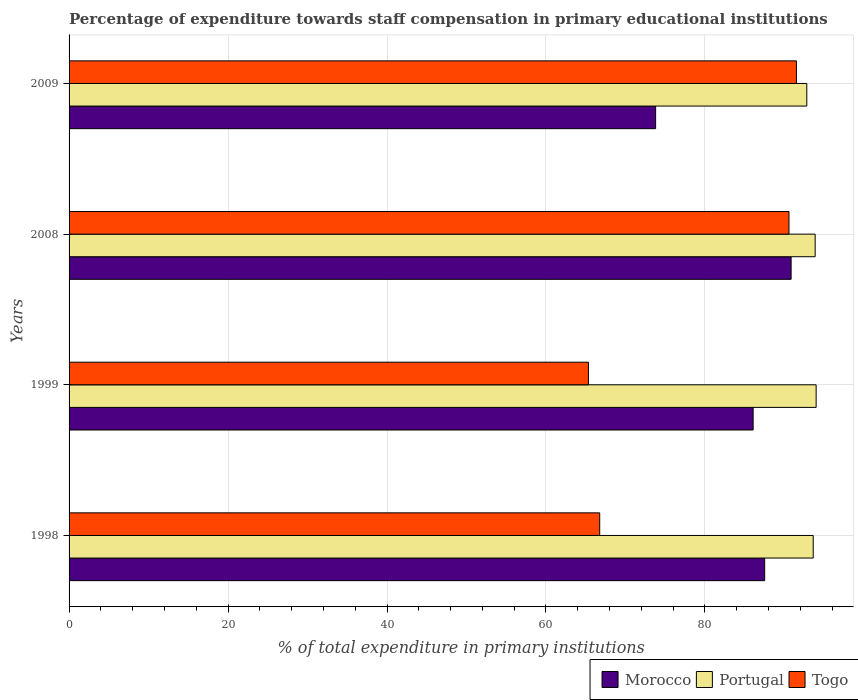How many different coloured bars are there?
Your response must be concise. 3. Are the number of bars per tick equal to the number of legend labels?
Your answer should be compact. Yes. What is the label of the 4th group of bars from the top?
Keep it short and to the point. 1998. In how many cases, is the number of bars for a given year not equal to the number of legend labels?
Ensure brevity in your answer.  0. What is the percentage of expenditure towards staff compensation in Togo in 2009?
Make the answer very short. 91.51. Across all years, what is the maximum percentage of expenditure towards staff compensation in Portugal?
Make the answer very short. 93.99. Across all years, what is the minimum percentage of expenditure towards staff compensation in Togo?
Ensure brevity in your answer.  65.34. In which year was the percentage of expenditure towards staff compensation in Portugal minimum?
Ensure brevity in your answer.  2009. What is the total percentage of expenditure towards staff compensation in Portugal in the graph?
Your response must be concise. 374.3. What is the difference between the percentage of expenditure towards staff compensation in Togo in 1999 and that in 2009?
Ensure brevity in your answer.  -26.17. What is the difference between the percentage of expenditure towards staff compensation in Morocco in 2009 and the percentage of expenditure towards staff compensation in Portugal in 1998?
Give a very brief answer. -19.83. What is the average percentage of expenditure towards staff compensation in Portugal per year?
Your response must be concise. 93.58. In the year 2009, what is the difference between the percentage of expenditure towards staff compensation in Morocco and percentage of expenditure towards staff compensation in Portugal?
Your response must be concise. -19.02. What is the ratio of the percentage of expenditure towards staff compensation in Togo in 2008 to that in 2009?
Provide a succinct answer. 0.99. Is the percentage of expenditure towards staff compensation in Portugal in 1998 less than that in 1999?
Offer a terse response. Yes. What is the difference between the highest and the second highest percentage of expenditure towards staff compensation in Morocco?
Keep it short and to the point. 3.33. What is the difference between the highest and the lowest percentage of expenditure towards staff compensation in Portugal?
Provide a succinct answer. 1.18. What does the 3rd bar from the top in 1998 represents?
Give a very brief answer. Morocco. What does the 2nd bar from the bottom in 1998 represents?
Provide a short and direct response. Portugal. How many bars are there?
Offer a very short reply. 12. What is the difference between two consecutive major ticks on the X-axis?
Your response must be concise. 20. Are the values on the major ticks of X-axis written in scientific E-notation?
Provide a succinct answer. No. Does the graph contain grids?
Offer a terse response. Yes. How many legend labels are there?
Your answer should be very brief. 3. How are the legend labels stacked?
Give a very brief answer. Horizontal. What is the title of the graph?
Offer a terse response. Percentage of expenditure towards staff compensation in primary educational institutions. Does "Mauritania" appear as one of the legend labels in the graph?
Keep it short and to the point. No. What is the label or title of the X-axis?
Give a very brief answer. % of total expenditure in primary institutions. What is the label or title of the Y-axis?
Your answer should be compact. Years. What is the % of total expenditure in primary institutions of Morocco in 1998?
Your answer should be compact. 87.52. What is the % of total expenditure in primary institutions of Portugal in 1998?
Your answer should be very brief. 93.63. What is the % of total expenditure in primary institutions in Togo in 1998?
Make the answer very short. 66.76. What is the % of total expenditure in primary institutions of Morocco in 1999?
Provide a succinct answer. 86.07. What is the % of total expenditure in primary institutions in Portugal in 1999?
Your response must be concise. 93.99. What is the % of total expenditure in primary institutions of Togo in 1999?
Your answer should be very brief. 65.34. What is the % of total expenditure in primary institutions of Morocco in 2008?
Keep it short and to the point. 90.84. What is the % of total expenditure in primary institutions in Portugal in 2008?
Make the answer very short. 93.87. What is the % of total expenditure in primary institutions in Togo in 2008?
Your answer should be compact. 90.57. What is the % of total expenditure in primary institutions of Morocco in 2009?
Provide a succinct answer. 73.8. What is the % of total expenditure in primary institutions in Portugal in 2009?
Your answer should be compact. 92.82. What is the % of total expenditure in primary institutions of Togo in 2009?
Provide a short and direct response. 91.51. Across all years, what is the maximum % of total expenditure in primary institutions of Morocco?
Provide a short and direct response. 90.84. Across all years, what is the maximum % of total expenditure in primary institutions in Portugal?
Provide a succinct answer. 93.99. Across all years, what is the maximum % of total expenditure in primary institutions in Togo?
Give a very brief answer. 91.51. Across all years, what is the minimum % of total expenditure in primary institutions in Morocco?
Provide a short and direct response. 73.8. Across all years, what is the minimum % of total expenditure in primary institutions of Portugal?
Your response must be concise. 92.82. Across all years, what is the minimum % of total expenditure in primary institutions in Togo?
Ensure brevity in your answer.  65.34. What is the total % of total expenditure in primary institutions of Morocco in the graph?
Make the answer very short. 338.22. What is the total % of total expenditure in primary institutions of Portugal in the graph?
Offer a terse response. 374.3. What is the total % of total expenditure in primary institutions of Togo in the graph?
Provide a succinct answer. 314.19. What is the difference between the % of total expenditure in primary institutions of Morocco in 1998 and that in 1999?
Your answer should be very brief. 1.45. What is the difference between the % of total expenditure in primary institutions of Portugal in 1998 and that in 1999?
Your answer should be compact. -0.37. What is the difference between the % of total expenditure in primary institutions in Togo in 1998 and that in 1999?
Your response must be concise. 1.42. What is the difference between the % of total expenditure in primary institutions of Morocco in 1998 and that in 2008?
Give a very brief answer. -3.33. What is the difference between the % of total expenditure in primary institutions of Portugal in 1998 and that in 2008?
Keep it short and to the point. -0.24. What is the difference between the % of total expenditure in primary institutions of Togo in 1998 and that in 2008?
Offer a terse response. -23.81. What is the difference between the % of total expenditure in primary institutions in Morocco in 1998 and that in 2009?
Ensure brevity in your answer.  13.72. What is the difference between the % of total expenditure in primary institutions in Portugal in 1998 and that in 2009?
Ensure brevity in your answer.  0.81. What is the difference between the % of total expenditure in primary institutions in Togo in 1998 and that in 2009?
Offer a terse response. -24.75. What is the difference between the % of total expenditure in primary institutions in Morocco in 1999 and that in 2008?
Your answer should be very brief. -4.78. What is the difference between the % of total expenditure in primary institutions in Portugal in 1999 and that in 2008?
Ensure brevity in your answer.  0.12. What is the difference between the % of total expenditure in primary institutions in Togo in 1999 and that in 2008?
Keep it short and to the point. -25.23. What is the difference between the % of total expenditure in primary institutions of Morocco in 1999 and that in 2009?
Give a very brief answer. 12.27. What is the difference between the % of total expenditure in primary institutions in Portugal in 1999 and that in 2009?
Your answer should be very brief. 1.18. What is the difference between the % of total expenditure in primary institutions of Togo in 1999 and that in 2009?
Your answer should be compact. -26.17. What is the difference between the % of total expenditure in primary institutions of Morocco in 2008 and that in 2009?
Your response must be concise. 17.05. What is the difference between the % of total expenditure in primary institutions of Portugal in 2008 and that in 2009?
Your answer should be very brief. 1.05. What is the difference between the % of total expenditure in primary institutions in Togo in 2008 and that in 2009?
Offer a terse response. -0.94. What is the difference between the % of total expenditure in primary institutions in Morocco in 1998 and the % of total expenditure in primary institutions in Portugal in 1999?
Your answer should be very brief. -6.48. What is the difference between the % of total expenditure in primary institutions of Morocco in 1998 and the % of total expenditure in primary institutions of Togo in 1999?
Ensure brevity in your answer.  22.17. What is the difference between the % of total expenditure in primary institutions in Portugal in 1998 and the % of total expenditure in primary institutions in Togo in 1999?
Your response must be concise. 28.28. What is the difference between the % of total expenditure in primary institutions in Morocco in 1998 and the % of total expenditure in primary institutions in Portugal in 2008?
Offer a terse response. -6.35. What is the difference between the % of total expenditure in primary institutions of Morocco in 1998 and the % of total expenditure in primary institutions of Togo in 2008?
Provide a short and direct response. -3.06. What is the difference between the % of total expenditure in primary institutions in Portugal in 1998 and the % of total expenditure in primary institutions in Togo in 2008?
Your answer should be very brief. 3.05. What is the difference between the % of total expenditure in primary institutions in Morocco in 1998 and the % of total expenditure in primary institutions in Portugal in 2009?
Your response must be concise. -5.3. What is the difference between the % of total expenditure in primary institutions in Morocco in 1998 and the % of total expenditure in primary institutions in Togo in 2009?
Offer a very short reply. -3.99. What is the difference between the % of total expenditure in primary institutions of Portugal in 1998 and the % of total expenditure in primary institutions of Togo in 2009?
Your response must be concise. 2.12. What is the difference between the % of total expenditure in primary institutions of Morocco in 1999 and the % of total expenditure in primary institutions of Portugal in 2008?
Offer a very short reply. -7.8. What is the difference between the % of total expenditure in primary institutions of Morocco in 1999 and the % of total expenditure in primary institutions of Togo in 2008?
Offer a terse response. -4.51. What is the difference between the % of total expenditure in primary institutions of Portugal in 1999 and the % of total expenditure in primary institutions of Togo in 2008?
Your answer should be very brief. 3.42. What is the difference between the % of total expenditure in primary institutions of Morocco in 1999 and the % of total expenditure in primary institutions of Portugal in 2009?
Ensure brevity in your answer.  -6.75. What is the difference between the % of total expenditure in primary institutions of Morocco in 1999 and the % of total expenditure in primary institutions of Togo in 2009?
Keep it short and to the point. -5.44. What is the difference between the % of total expenditure in primary institutions of Portugal in 1999 and the % of total expenditure in primary institutions of Togo in 2009?
Your answer should be compact. 2.48. What is the difference between the % of total expenditure in primary institutions of Morocco in 2008 and the % of total expenditure in primary institutions of Portugal in 2009?
Your answer should be very brief. -1.97. What is the difference between the % of total expenditure in primary institutions in Morocco in 2008 and the % of total expenditure in primary institutions in Togo in 2009?
Offer a very short reply. -0.67. What is the difference between the % of total expenditure in primary institutions of Portugal in 2008 and the % of total expenditure in primary institutions of Togo in 2009?
Offer a terse response. 2.36. What is the average % of total expenditure in primary institutions of Morocco per year?
Your answer should be very brief. 84.56. What is the average % of total expenditure in primary institutions in Portugal per year?
Offer a terse response. 93.58. What is the average % of total expenditure in primary institutions of Togo per year?
Provide a short and direct response. 78.55. In the year 1998, what is the difference between the % of total expenditure in primary institutions in Morocco and % of total expenditure in primary institutions in Portugal?
Make the answer very short. -6.11. In the year 1998, what is the difference between the % of total expenditure in primary institutions of Morocco and % of total expenditure in primary institutions of Togo?
Provide a succinct answer. 20.75. In the year 1998, what is the difference between the % of total expenditure in primary institutions in Portugal and % of total expenditure in primary institutions in Togo?
Make the answer very short. 26.86. In the year 1999, what is the difference between the % of total expenditure in primary institutions in Morocco and % of total expenditure in primary institutions in Portugal?
Your response must be concise. -7.93. In the year 1999, what is the difference between the % of total expenditure in primary institutions in Morocco and % of total expenditure in primary institutions in Togo?
Offer a very short reply. 20.72. In the year 1999, what is the difference between the % of total expenditure in primary institutions of Portugal and % of total expenditure in primary institutions of Togo?
Ensure brevity in your answer.  28.65. In the year 2008, what is the difference between the % of total expenditure in primary institutions of Morocco and % of total expenditure in primary institutions of Portugal?
Give a very brief answer. -3.03. In the year 2008, what is the difference between the % of total expenditure in primary institutions in Morocco and % of total expenditure in primary institutions in Togo?
Your response must be concise. 0.27. In the year 2008, what is the difference between the % of total expenditure in primary institutions of Portugal and % of total expenditure in primary institutions of Togo?
Keep it short and to the point. 3.29. In the year 2009, what is the difference between the % of total expenditure in primary institutions in Morocco and % of total expenditure in primary institutions in Portugal?
Make the answer very short. -19.02. In the year 2009, what is the difference between the % of total expenditure in primary institutions in Morocco and % of total expenditure in primary institutions in Togo?
Your response must be concise. -17.71. In the year 2009, what is the difference between the % of total expenditure in primary institutions in Portugal and % of total expenditure in primary institutions in Togo?
Your answer should be very brief. 1.31. What is the ratio of the % of total expenditure in primary institutions in Morocco in 1998 to that in 1999?
Your answer should be compact. 1.02. What is the ratio of the % of total expenditure in primary institutions in Portugal in 1998 to that in 1999?
Provide a succinct answer. 1. What is the ratio of the % of total expenditure in primary institutions of Togo in 1998 to that in 1999?
Keep it short and to the point. 1.02. What is the ratio of the % of total expenditure in primary institutions of Morocco in 1998 to that in 2008?
Ensure brevity in your answer.  0.96. What is the ratio of the % of total expenditure in primary institutions of Togo in 1998 to that in 2008?
Your response must be concise. 0.74. What is the ratio of the % of total expenditure in primary institutions of Morocco in 1998 to that in 2009?
Offer a terse response. 1.19. What is the ratio of the % of total expenditure in primary institutions in Portugal in 1998 to that in 2009?
Give a very brief answer. 1.01. What is the ratio of the % of total expenditure in primary institutions of Togo in 1998 to that in 2009?
Ensure brevity in your answer.  0.73. What is the ratio of the % of total expenditure in primary institutions in Morocco in 1999 to that in 2008?
Your answer should be very brief. 0.95. What is the ratio of the % of total expenditure in primary institutions of Portugal in 1999 to that in 2008?
Keep it short and to the point. 1. What is the ratio of the % of total expenditure in primary institutions of Togo in 1999 to that in 2008?
Offer a terse response. 0.72. What is the ratio of the % of total expenditure in primary institutions in Morocco in 1999 to that in 2009?
Keep it short and to the point. 1.17. What is the ratio of the % of total expenditure in primary institutions in Portugal in 1999 to that in 2009?
Keep it short and to the point. 1.01. What is the ratio of the % of total expenditure in primary institutions of Togo in 1999 to that in 2009?
Your response must be concise. 0.71. What is the ratio of the % of total expenditure in primary institutions of Morocco in 2008 to that in 2009?
Keep it short and to the point. 1.23. What is the ratio of the % of total expenditure in primary institutions of Portugal in 2008 to that in 2009?
Provide a short and direct response. 1.01. What is the ratio of the % of total expenditure in primary institutions of Togo in 2008 to that in 2009?
Offer a terse response. 0.99. What is the difference between the highest and the second highest % of total expenditure in primary institutions in Morocco?
Provide a short and direct response. 3.33. What is the difference between the highest and the second highest % of total expenditure in primary institutions of Portugal?
Your answer should be very brief. 0.12. What is the difference between the highest and the second highest % of total expenditure in primary institutions in Togo?
Provide a short and direct response. 0.94. What is the difference between the highest and the lowest % of total expenditure in primary institutions of Morocco?
Ensure brevity in your answer.  17.05. What is the difference between the highest and the lowest % of total expenditure in primary institutions in Portugal?
Provide a succinct answer. 1.18. What is the difference between the highest and the lowest % of total expenditure in primary institutions in Togo?
Your answer should be compact. 26.17. 